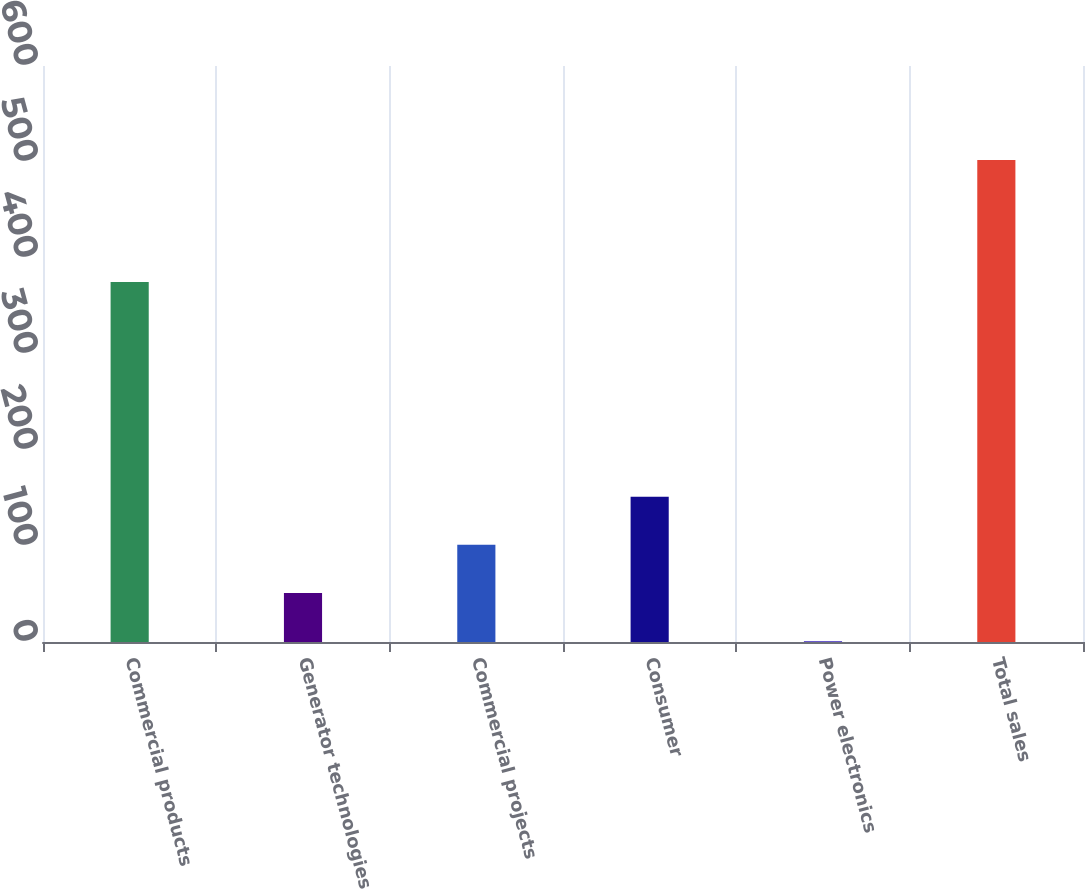<chart> <loc_0><loc_0><loc_500><loc_500><bar_chart><fcel>Commercial products<fcel>Generator technologies<fcel>Commercial projects<fcel>Consumer<fcel>Power electronics<fcel>Total sales<nl><fcel>375<fcel>51.1<fcel>101.2<fcel>151.3<fcel>1<fcel>502<nl></chart> 